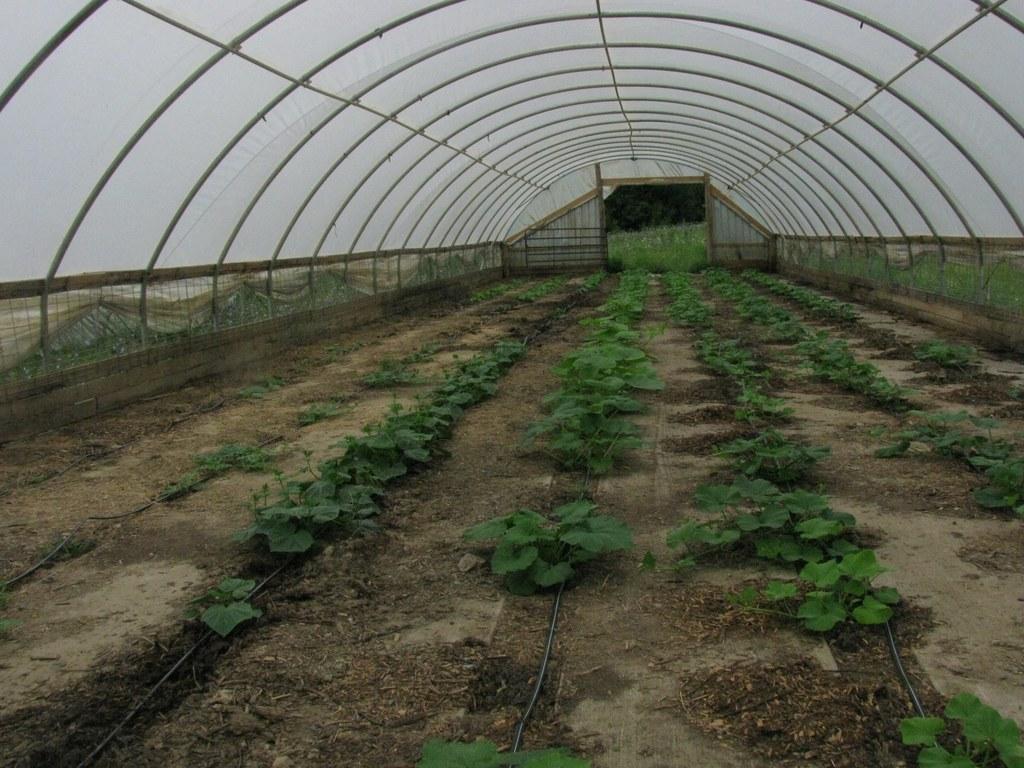Please provide a concise description of this image. In this image, we can see some green color plants, at the top there is a shed. 